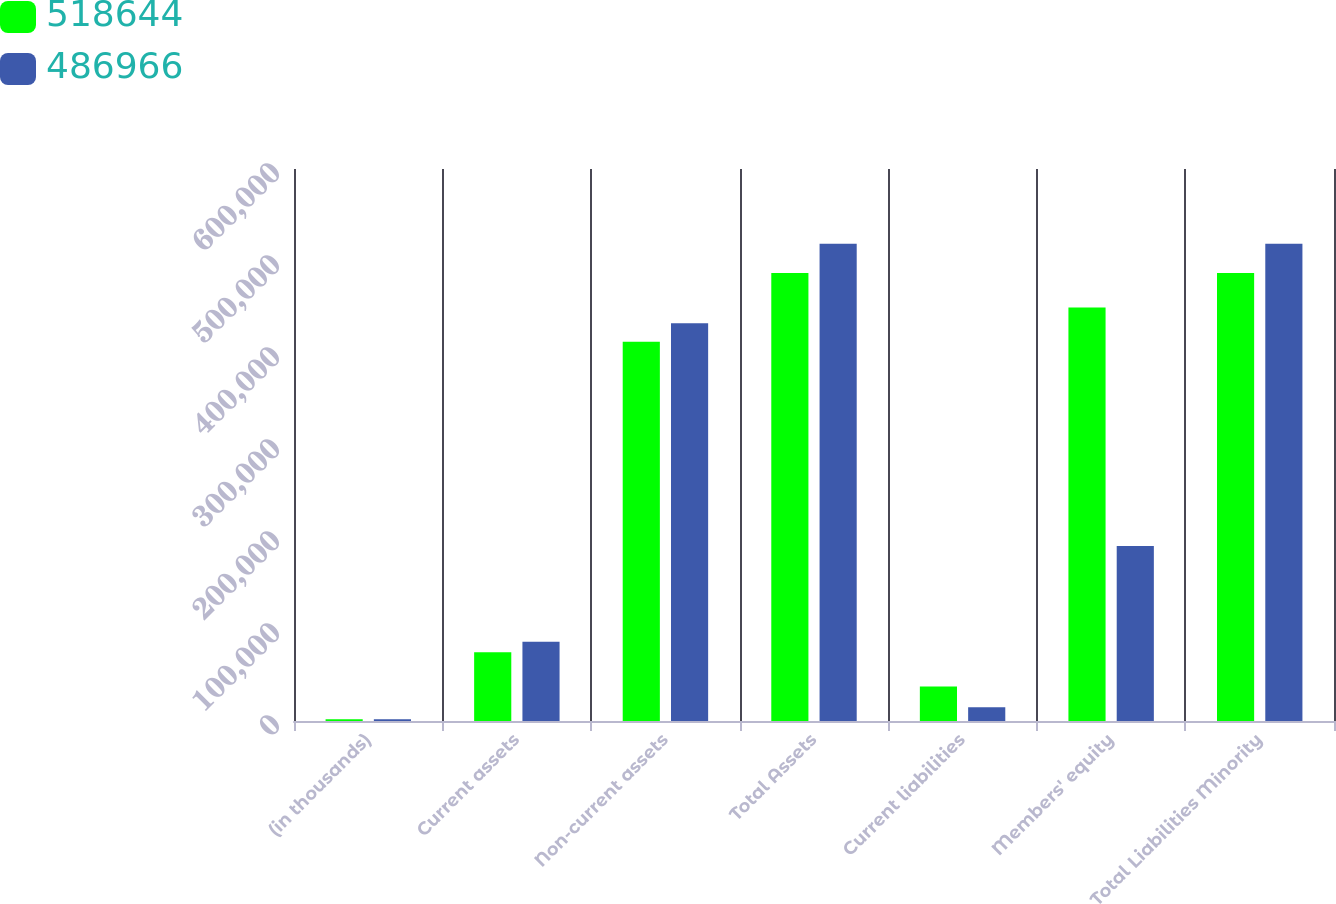<chart> <loc_0><loc_0><loc_500><loc_500><stacked_bar_chart><ecel><fcel>(in thousands)<fcel>Current assets<fcel>Non-current assets<fcel>Total Assets<fcel>Current liabilities<fcel>Members' equity<fcel>Total Liabilities Minority<nl><fcel>518644<fcel>2002<fcel>74832<fcel>412134<fcel>486966<fcel>37419<fcel>449547<fcel>486966<nl><fcel>486966<fcel>2001<fcel>86213<fcel>432431<fcel>518644<fcel>14892<fcel>190136<fcel>518644<nl></chart> 